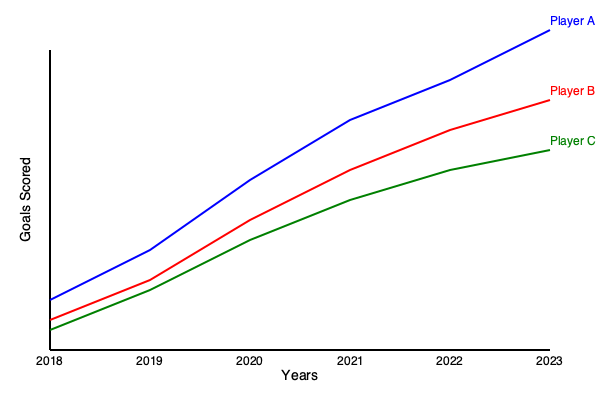Based on the line graph showing goal-scoring trends of three top international footballers from 2018 to 2023, which player has demonstrated the most consistent improvement in their goal-scoring performance, and what does this suggest about their career trajectory? To determine which player has shown the most consistent improvement, we need to analyze the slope and pattern of each player's line:

1. Player A (blue line):
   - Starts with the lowest goals in 2018
   - Shows rapid improvement from 2018 to 2021
   - Continues to improve but at a slightly slower rate from 2021 to 2023
   - Overall, very steep upward trajectory

2. Player B (red line):
   - Starts in the middle position in 2018
   - Shows steady improvement throughout the years
   - The slope is relatively consistent, indicating regular progress
   - Ends up in the middle position in 2023

3. Player C (green line):
   - Starts with the highest goals in 2018
   - Shows the slowest rate of improvement
   - The line has the shallowest slope among the three players
   - Ends up with the lowest goals in 2023

Player A shows the most dramatic improvement but with some variation in the rate of progress. Player B demonstrates the most consistent improvement, with a steady upward slope throughout the entire period. Player C shows improvement but at a much slower and less consistent rate.

Given these observations, Player B has demonstrated the most consistent improvement in their goal-scoring performance. This suggests a career trajectory characterized by steady development, consistent training, and the ability to maintain progress over time. It may indicate good adaptability to different teams or playing conditions, as well as a strong work ethic and dedication to improving their skills year after year.
Answer: Player B; steady career development and consistent skill improvement. 